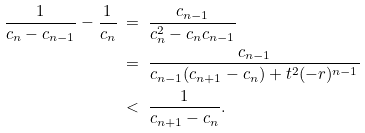Convert formula to latex. <formula><loc_0><loc_0><loc_500><loc_500>\frac { 1 } { c _ { n } - c _ { n - 1 } } - \frac { 1 } { c _ { n } } & \ = \ \frac { c _ { n - 1 } } { c _ { n } ^ { 2 } - c _ { n } c _ { n - 1 } } \\ & \ = \ \frac { c _ { n - 1 } } { c _ { n - 1 } ( c _ { n + 1 } - c _ { n } ) + t ^ { 2 } ( - r ) ^ { n - 1 } } \\ & \ < \ \frac { 1 } { c _ { n + 1 } - c _ { n } } .</formula> 